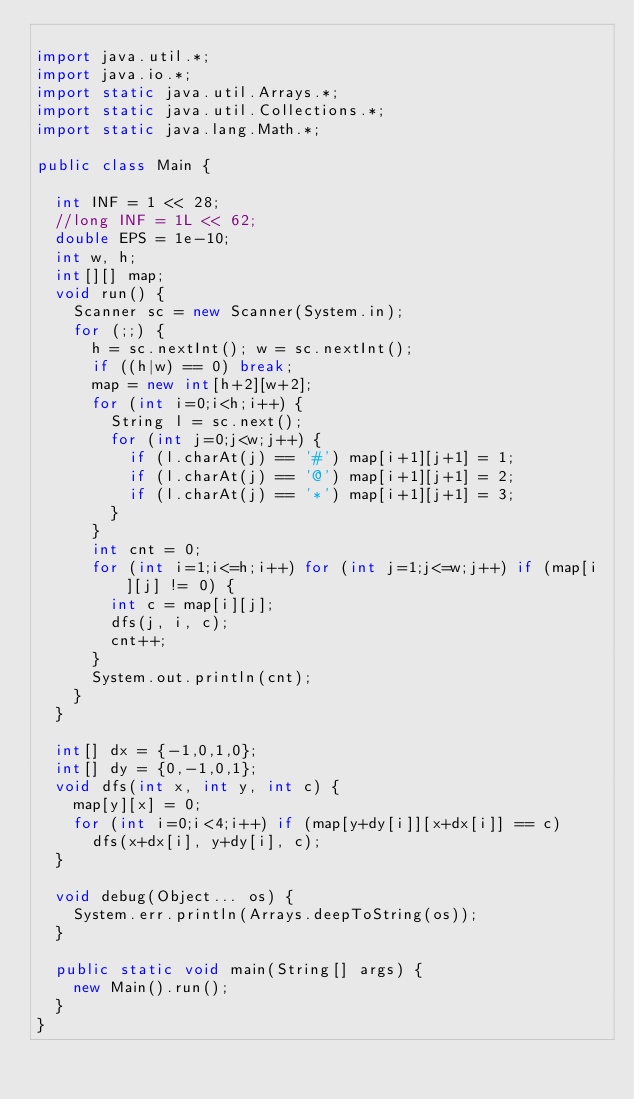Convert code to text. <code><loc_0><loc_0><loc_500><loc_500><_Java_>
import java.util.*;
import java.io.*;
import static java.util.Arrays.*;
import static java.util.Collections.*;
import static java.lang.Math.*;

public class Main {

	int INF = 1 << 28;
	//long INF = 1L << 62;
	double EPS = 1e-10;
	int w, h;
	int[][] map;
	void run() {
		Scanner sc = new Scanner(System.in);
		for (;;) {
			h = sc.nextInt(); w = sc.nextInt();
			if ((h|w) == 0) break;
			map = new int[h+2][w+2];
			for (int i=0;i<h;i++) {
				String l = sc.next();
				for (int j=0;j<w;j++) {
					if (l.charAt(j) == '#') map[i+1][j+1] = 1;
					if (l.charAt(j) == '@') map[i+1][j+1] = 2;
					if (l.charAt(j) == '*') map[i+1][j+1] = 3;
				}
			}
			int cnt = 0;
			for (int i=1;i<=h;i++) for (int j=1;j<=w;j++) if (map[i][j] != 0) {
				int c = map[i][j];
				dfs(j, i, c);
				cnt++;
			}
			System.out.println(cnt);
		}
	}

	int[] dx = {-1,0,1,0};
	int[] dy = {0,-1,0,1};
	void dfs(int x, int y, int c) {
		map[y][x] = 0;
		for (int i=0;i<4;i++) if (map[y+dy[i]][x+dx[i]] == c)
			dfs(x+dx[i], y+dy[i], c);
	}

	void debug(Object... os) {
		System.err.println(Arrays.deepToString(os));
	}

	public static void main(String[] args) {
		new Main().run();
	}
}</code> 